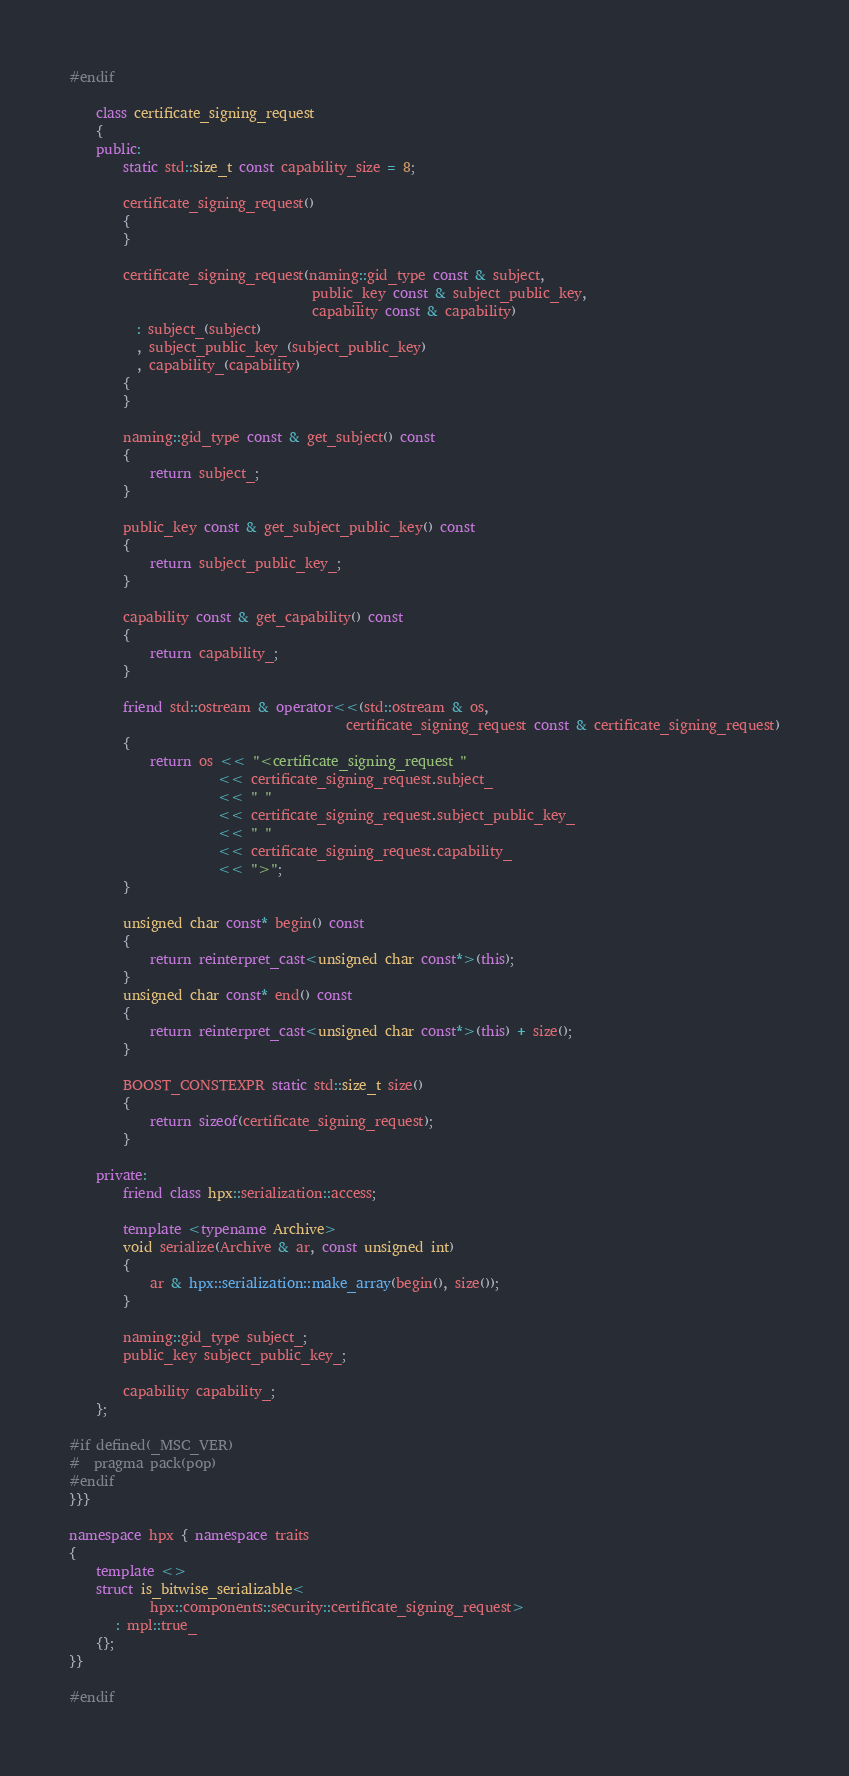<code> <loc_0><loc_0><loc_500><loc_500><_C++_>#endif

    class certificate_signing_request
    {
    public:
        static std::size_t const capability_size = 8;

        certificate_signing_request()
        {
        }

        certificate_signing_request(naming::gid_type const & subject,
                                    public_key const & subject_public_key,
                                    capability const & capability)
          : subject_(subject)
          , subject_public_key_(subject_public_key)
          , capability_(capability)
        {
        }

        naming::gid_type const & get_subject() const
        {
            return subject_;
        }

        public_key const & get_subject_public_key() const
        {
            return subject_public_key_;
        }

        capability const & get_capability() const
        {
            return capability_;
        }

        friend std::ostream & operator<<(std::ostream & os,
                                         certificate_signing_request const & certificate_signing_request)
        {
            return os << "<certificate_signing_request "
                      << certificate_signing_request.subject_
                      << " "
                      << certificate_signing_request.subject_public_key_
                      << " "
                      << certificate_signing_request.capability_
                      << ">";
        }

        unsigned char const* begin() const
        {
            return reinterpret_cast<unsigned char const*>(this);
        }
        unsigned char const* end() const
        {
            return reinterpret_cast<unsigned char const*>(this) + size();
        }

        BOOST_CONSTEXPR static std::size_t size()
        {
            return sizeof(certificate_signing_request);
        }

    private:
        friend class hpx::serialization::access;

        template <typename Archive>
        void serialize(Archive & ar, const unsigned int)
        {
            ar & hpx::serialization::make_array(begin(), size());
        }

        naming::gid_type subject_;
        public_key subject_public_key_;

        capability capability_;
    };

#if defined(_MSC_VER)
#  pragma pack(pop)
#endif
}}}

namespace hpx { namespace traits
{
    template <>
    struct is_bitwise_serializable<
            hpx::components::security::certificate_signing_request>
       : mpl::true_
    {};
}}

#endif
</code> 